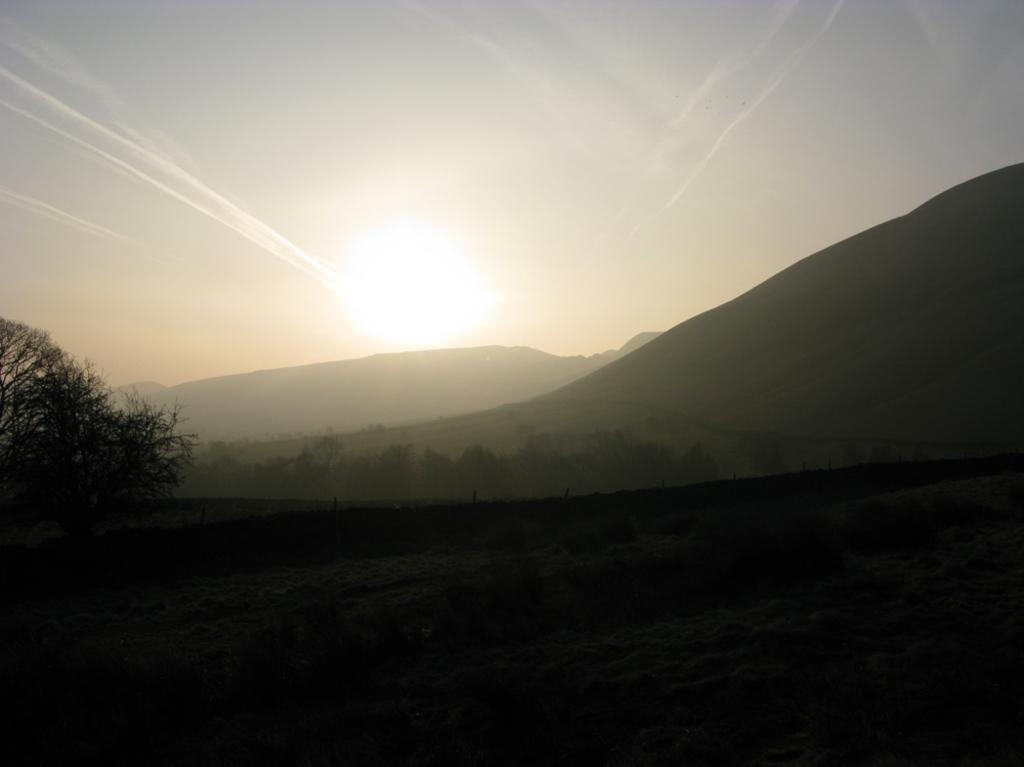What type of vegetation is present in the image? There is a tree in the image. What geographical features can be seen in the image? There are mountains in the image. What part of the natural environment is visible in the image? The sky is visible in the image. Where is the army located in the image? There is no army present in the image. Can you describe the type of bath that is visible in the image? There is no bath present in the image. 